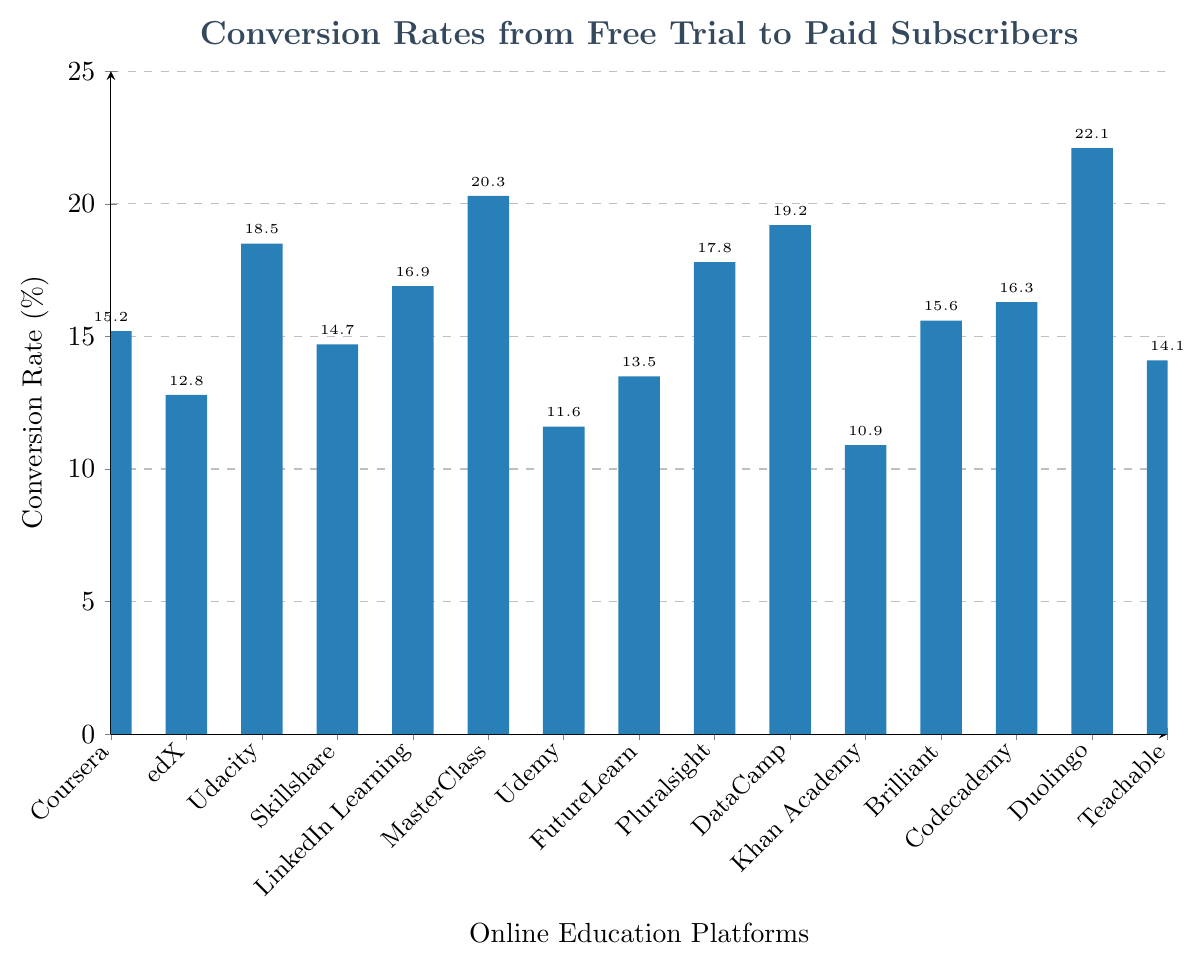What's the highest conversion rate and which platform does it belong to? By examining the highest bar in the chart, the highest conversion rate is indicated by the tallest bar. According to the figure, the tallest bar corresponds to Duolingo, reaching the top conversion rate of 22.1%.
Answer: Duolingo, 22.1% Which platform has the lowest conversion rate and what is its rate? Identifying the shortest bar in the chart will show the platform with the lowest conversion rate. The figure shows that Khan Academy has the shortest bar, indicating the lowest conversion rate of 10.9%.
Answer: Khan Academy, 10.9% What is the average conversion rate across all platforms? To find the average, sum up all the conversion rates and divide by the number of platforms: (15.2 + 12.8 + 18.5 + 14.7 + 16.9 + 20.3 + 11.6 + 13.5 + 17.8 + 19.2 + 10.9 + 15.6 + 16.3 + 22.1 + 14.1) / 15 = 245.5 / 15 = 16.37%
Answer: 16.37% Which platform has a higher conversion rate, Udacity or Pluralsight, and by how much? Compare the heights of the bars for Udacity and Pluralsight. The conversion rates are 18.5% and 17.8% respectively. The difference is 18.5% - 17.8% = 0.7%. Hence, Udacity has a higher conversion rate by 0.7%.
Answer: Udacity by 0.7% Name the platforms with conversion rates greater than 18%. Reviewing the chart, the platforms with bars reaching taller than 18% are Duolingo (22.1%), MasterClass (20.3%), DataCamp (19.2%), and Udacity (18.5%).
Answer: Duolingo, MasterClass, DataCamp, Udacity How much higher is Coursera’s conversion rate than Udemy's? By looking at the bars for Coursera and Udemy, their conversion rates are 15.2% and 11.6%, respectively. Subtract Udemy's rate from Coursera's: 15.2% - 11.6% = 3.6%.
Answer: 3.6% What is the median conversion rate of the platforms? To find the median, sort the conversion rates: 10.9, 11.6, 12.8, 13.5, 14.1, 14.7, 15.2, 15.6, 16.3, 16.9, 17.8, 18.5, 19.2, 20.3, 22.1. The middle value of this ordered list (the 8th value) is 15.6%.
Answer: 15.6% How many platforms have conversion rates below the average rate? First, recall the average rate is 16.37%. Count the platforms with conversion rates less than this value: edX (12.8%), Udemy (11.6%), Skillshare (14.7%), FutureLearn (13.5%), Khan Academy (10.9%), Teachable (14.1%). There are 6 platforms.
Answer: 6 platforms What’s the range of the conversion rates? The range is calculated by subtracting the lowest conversion rate from the highest: 22.1% (Duolingo) - 10.9% (Khan Academy) = 11.2%.
Answer: 11.2% 